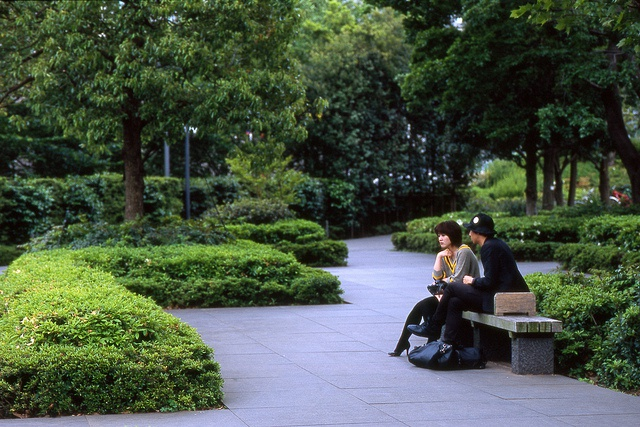Describe the objects in this image and their specific colors. I can see people in darkgreen, black, gray, and brown tones, bench in darkgreen, black, gray, and darkgray tones, people in darkgreen, black, gray, darkgray, and lavender tones, and backpack in darkgreen, black, gray, and navy tones in this image. 